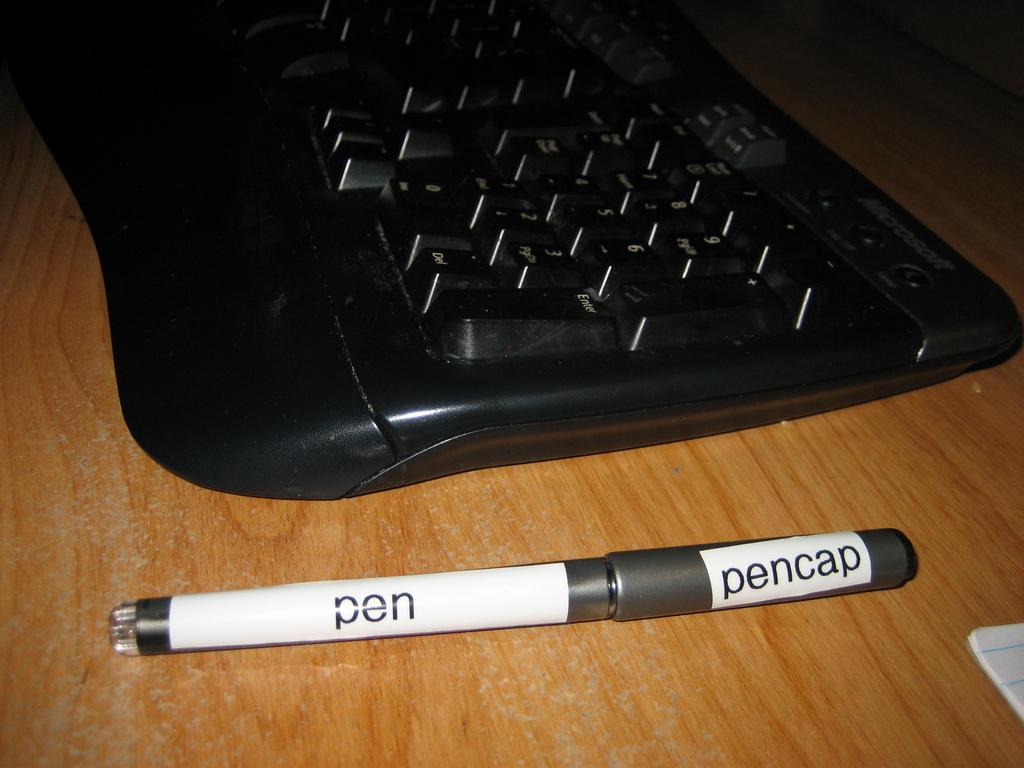What does the pencap say?
Offer a very short reply. Pencap. What brand is this keyboard?
Make the answer very short. Microsoft. 